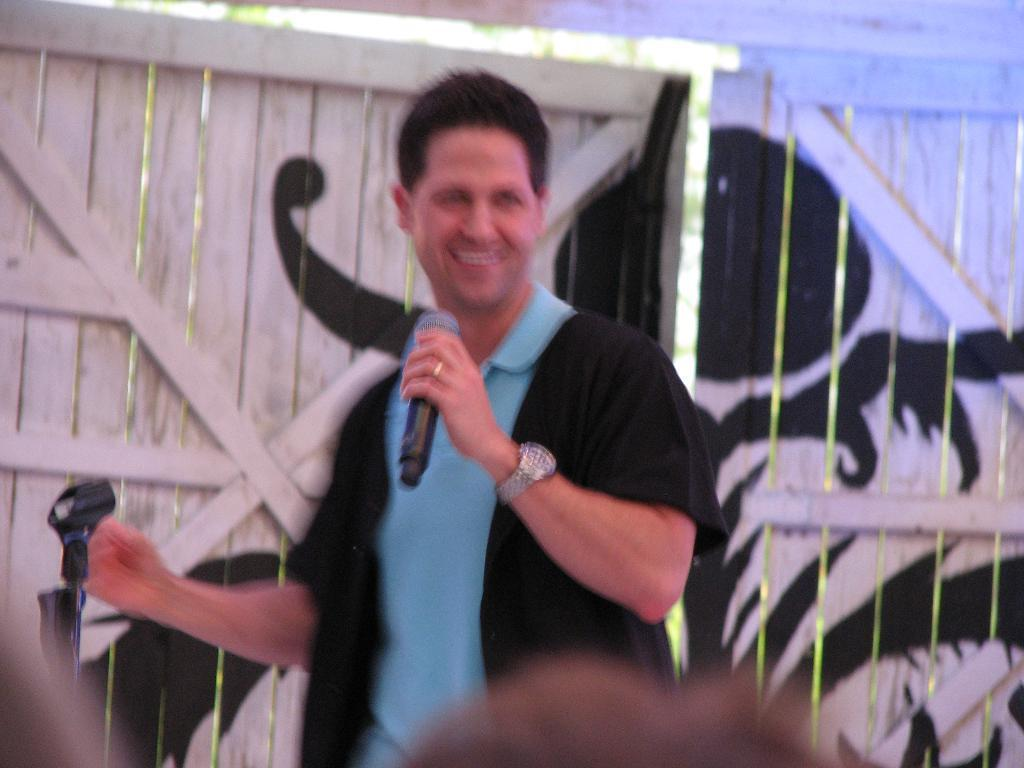What is the main subject of the image? The main subject of the image is a man standing in the middle. What is the man holding in his left hand? The man is holding a microphone in his left hand. What is the man's facial expression? The man is smiling. What color is the t-shirt the man is wearing? The man is wearing a blue color t-shirt. What can be seen in the background of the image? There is a wooden door in the background of the image. How many dinosaurs are present in the image? There are no dinosaurs present in the image. What type of doll is the man holding in his right hand? The man is not holding a doll in his right hand; he is holding a microphone in his left hand. 